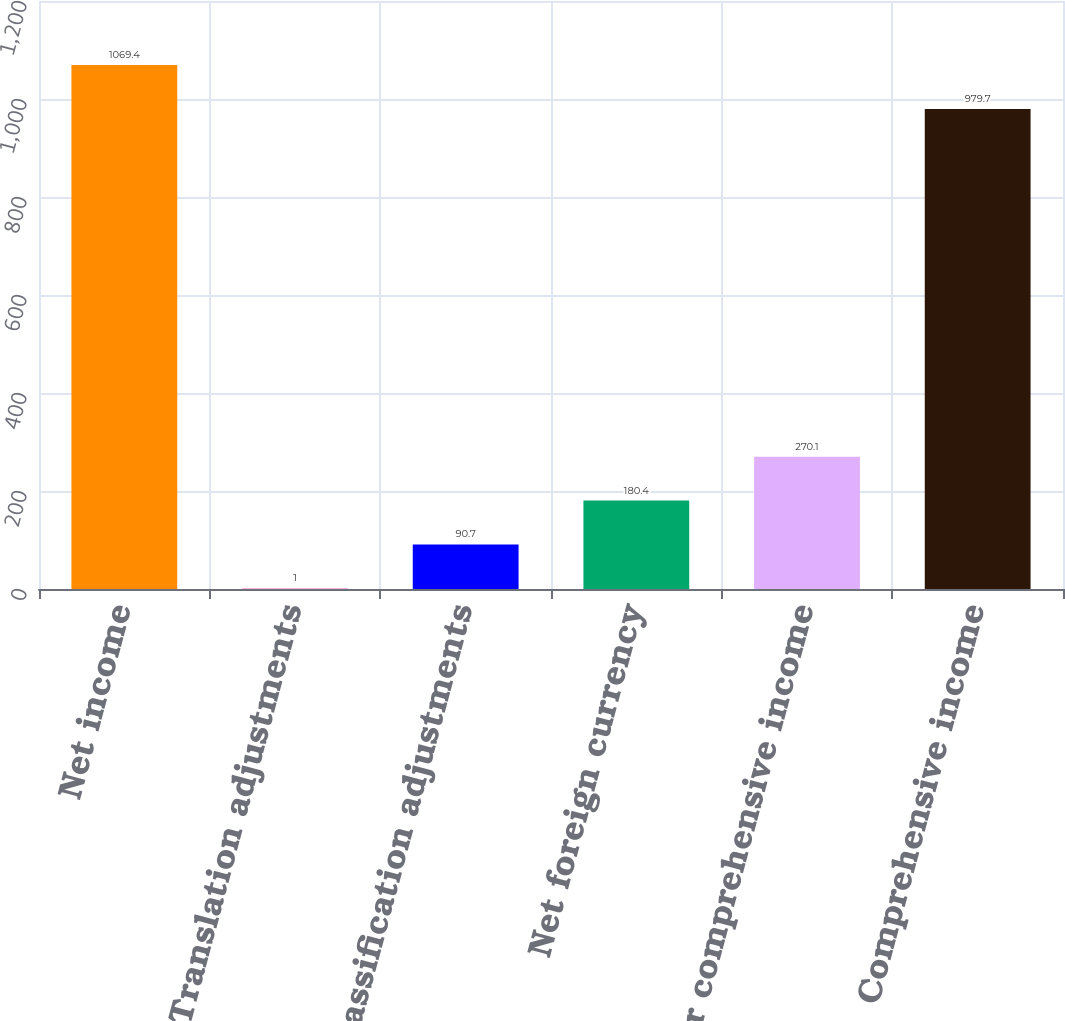Convert chart. <chart><loc_0><loc_0><loc_500><loc_500><bar_chart><fcel>Net income<fcel>Translation adjustments<fcel>Reclassification adjustments<fcel>Net foreign currency<fcel>Other comprehensive income<fcel>Comprehensive income<nl><fcel>1069.4<fcel>1<fcel>90.7<fcel>180.4<fcel>270.1<fcel>979.7<nl></chart> 